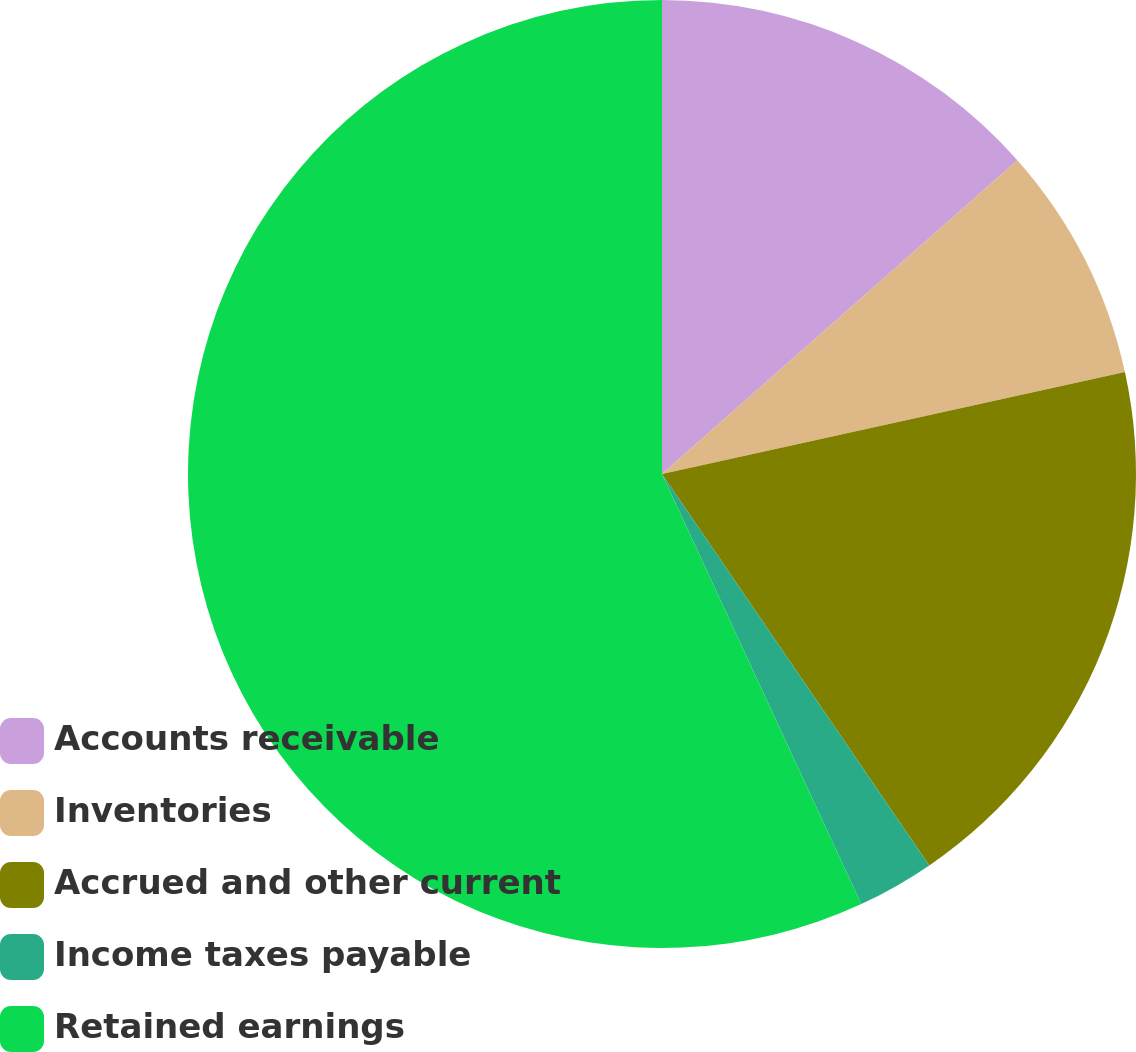Convert chart. <chart><loc_0><loc_0><loc_500><loc_500><pie_chart><fcel>Accounts receivable<fcel>Inventories<fcel>Accrued and other current<fcel>Income taxes payable<fcel>Retained earnings<nl><fcel>13.49%<fcel>8.06%<fcel>18.91%<fcel>2.63%<fcel>56.9%<nl></chart> 